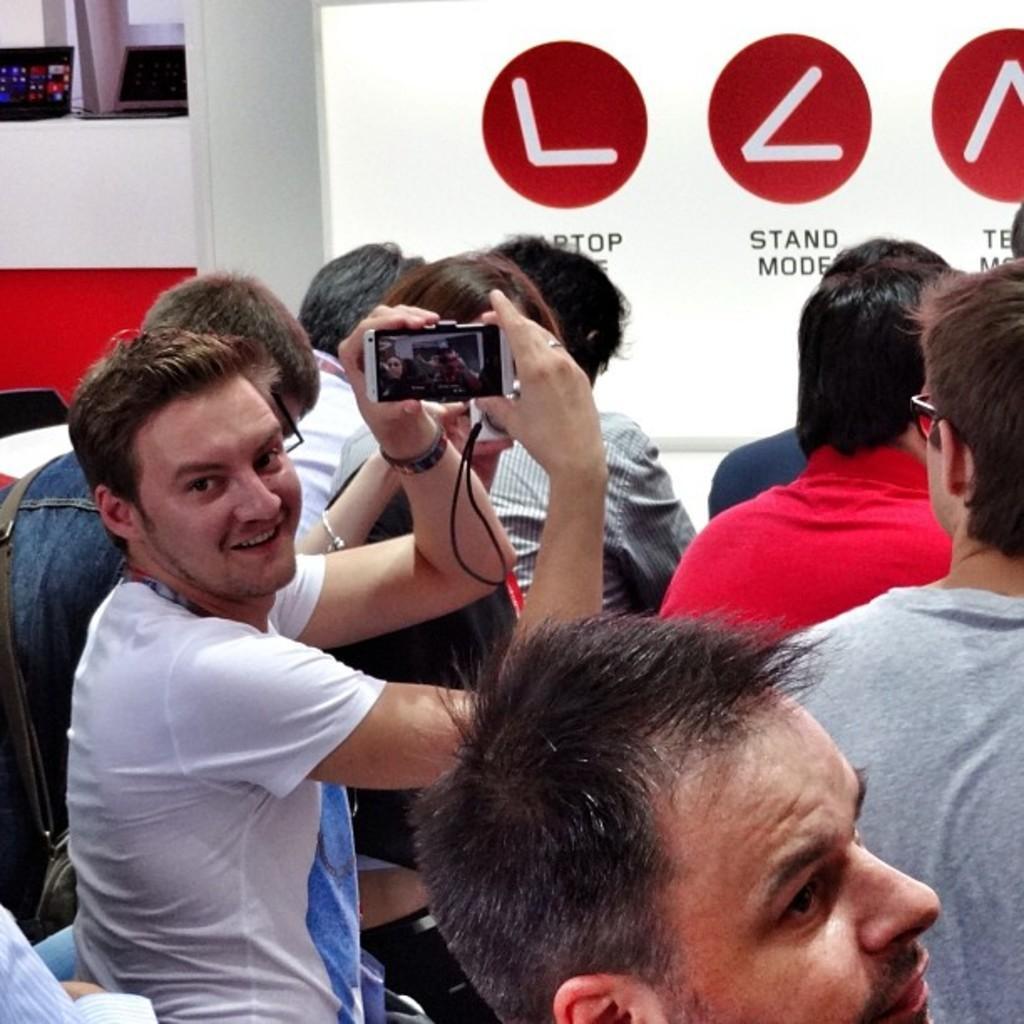Describe this image in one or two sentences. In this picture we can see a spectacle, device, bag and a group of people and a man smiling and in the background we can see a board with signs and text on it, laptops and some objects. 